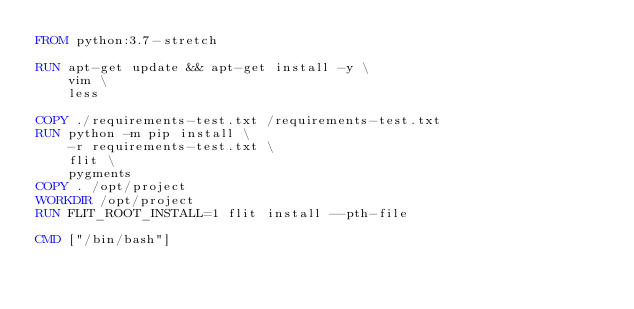<code> <loc_0><loc_0><loc_500><loc_500><_Dockerfile_>FROM python:3.7-stretch

RUN apt-get update && apt-get install -y \
    vim \
    less

COPY ./requirements-test.txt /requirements-test.txt
RUN python -m pip install \
    -r requirements-test.txt \
    flit \
    pygments
COPY . /opt/project
WORKDIR /opt/project
RUN FLIT_ROOT_INSTALL=1 flit install --pth-file

CMD ["/bin/bash"]
</code> 